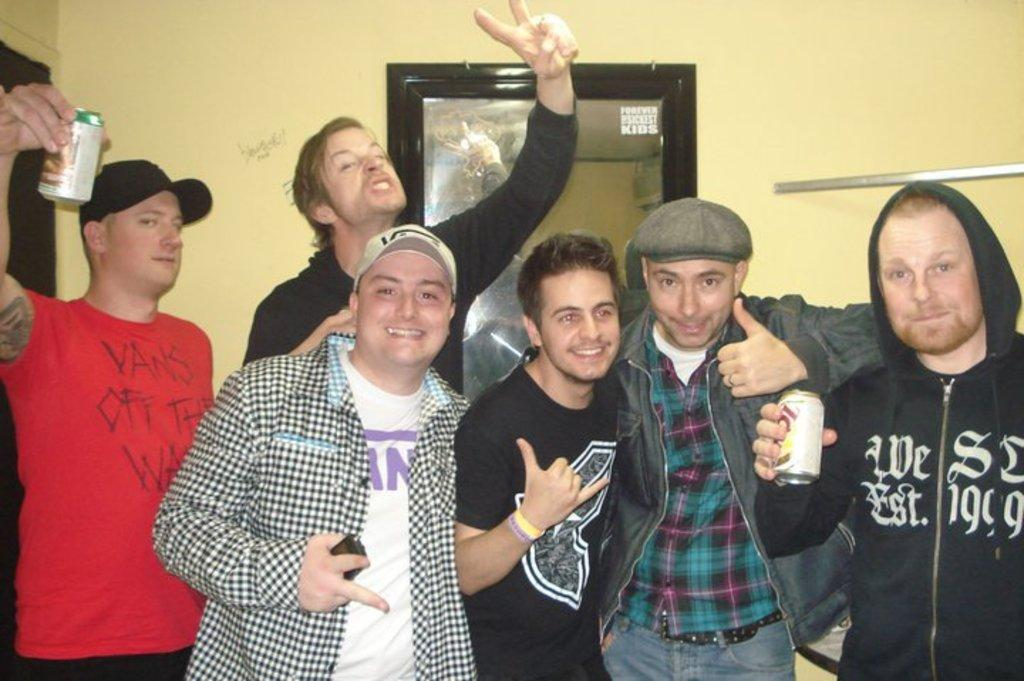Provide a one-sentence caption for the provided image. Six friends pose together, and two of them are wearing Vans shirts. 